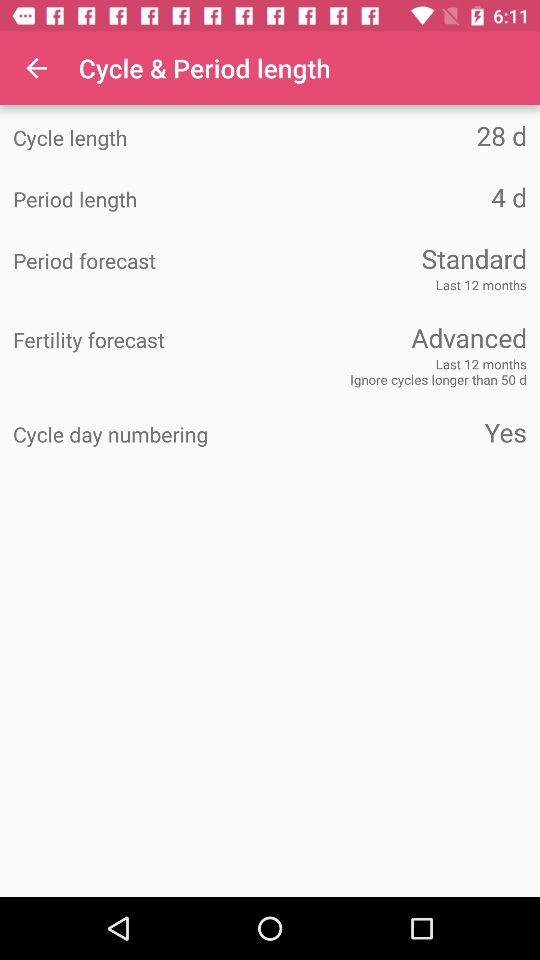How many months is the calculation of the standard period forecast based on? The calculation of the standard period forecast is based on the last 12 months. 